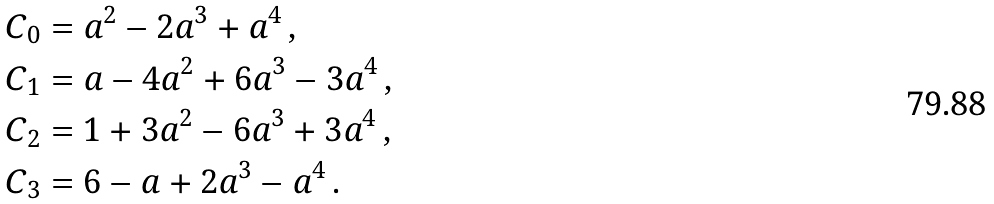Convert formula to latex. <formula><loc_0><loc_0><loc_500><loc_500>C _ { 0 } & = a ^ { 2 } - 2 a ^ { 3 } + a ^ { 4 } \, , \\ C _ { 1 } & = a - 4 a ^ { 2 } + 6 a ^ { 3 } - 3 a ^ { 4 } \, , \\ C _ { 2 } & = 1 + 3 a ^ { 2 } - 6 a ^ { 3 } + 3 a ^ { 4 } \, , \\ C _ { 3 } & = 6 - a + 2 a ^ { 3 } - a ^ { 4 } \, .</formula> 